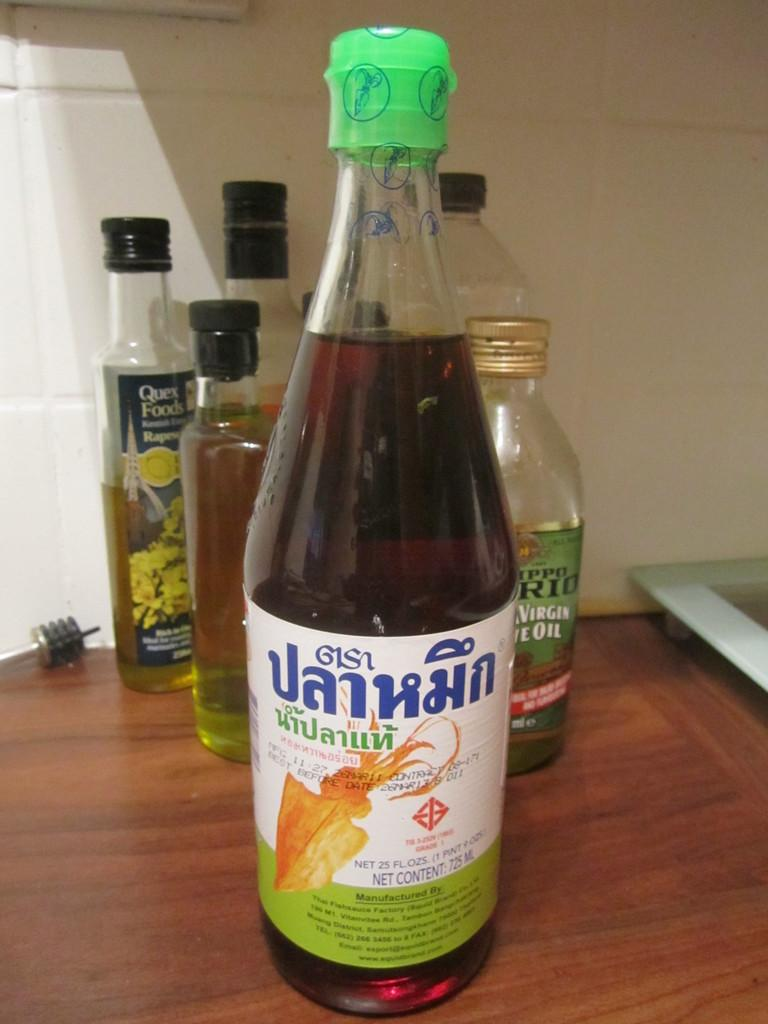What is the main subject of the image? The main subject of the image is many bottles. Can you describe the bottle in the foreground? The bottle in the foreground has a green cap. Where are the bottles located? The bottles are on a table. What can be seen in the background of the image? There is a white wall in the background. What type of ship can be seen in the image? There is no ship present in the image; it features many bottles on a table. What distribution method is being used for the bottles in the image? The image does not show any distribution method for the bottles; it simply shows them on a table. 